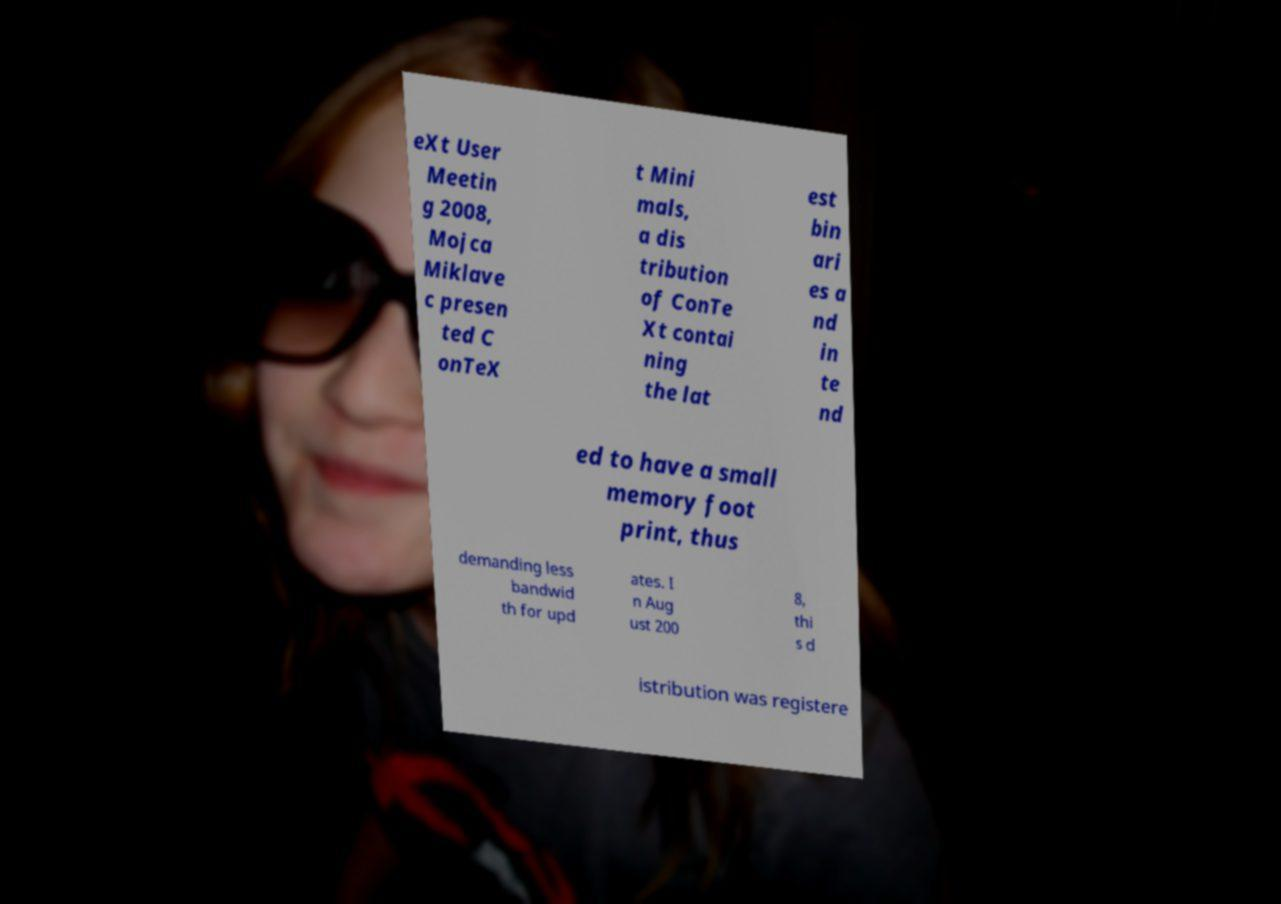There's text embedded in this image that I need extracted. Can you transcribe it verbatim? eXt User Meetin g 2008, Mojca Miklave c presen ted C onTeX t Mini mals, a dis tribution of ConTe Xt contai ning the lat est bin ari es a nd in te nd ed to have a small memory foot print, thus demanding less bandwid th for upd ates. I n Aug ust 200 8, thi s d istribution was registere 